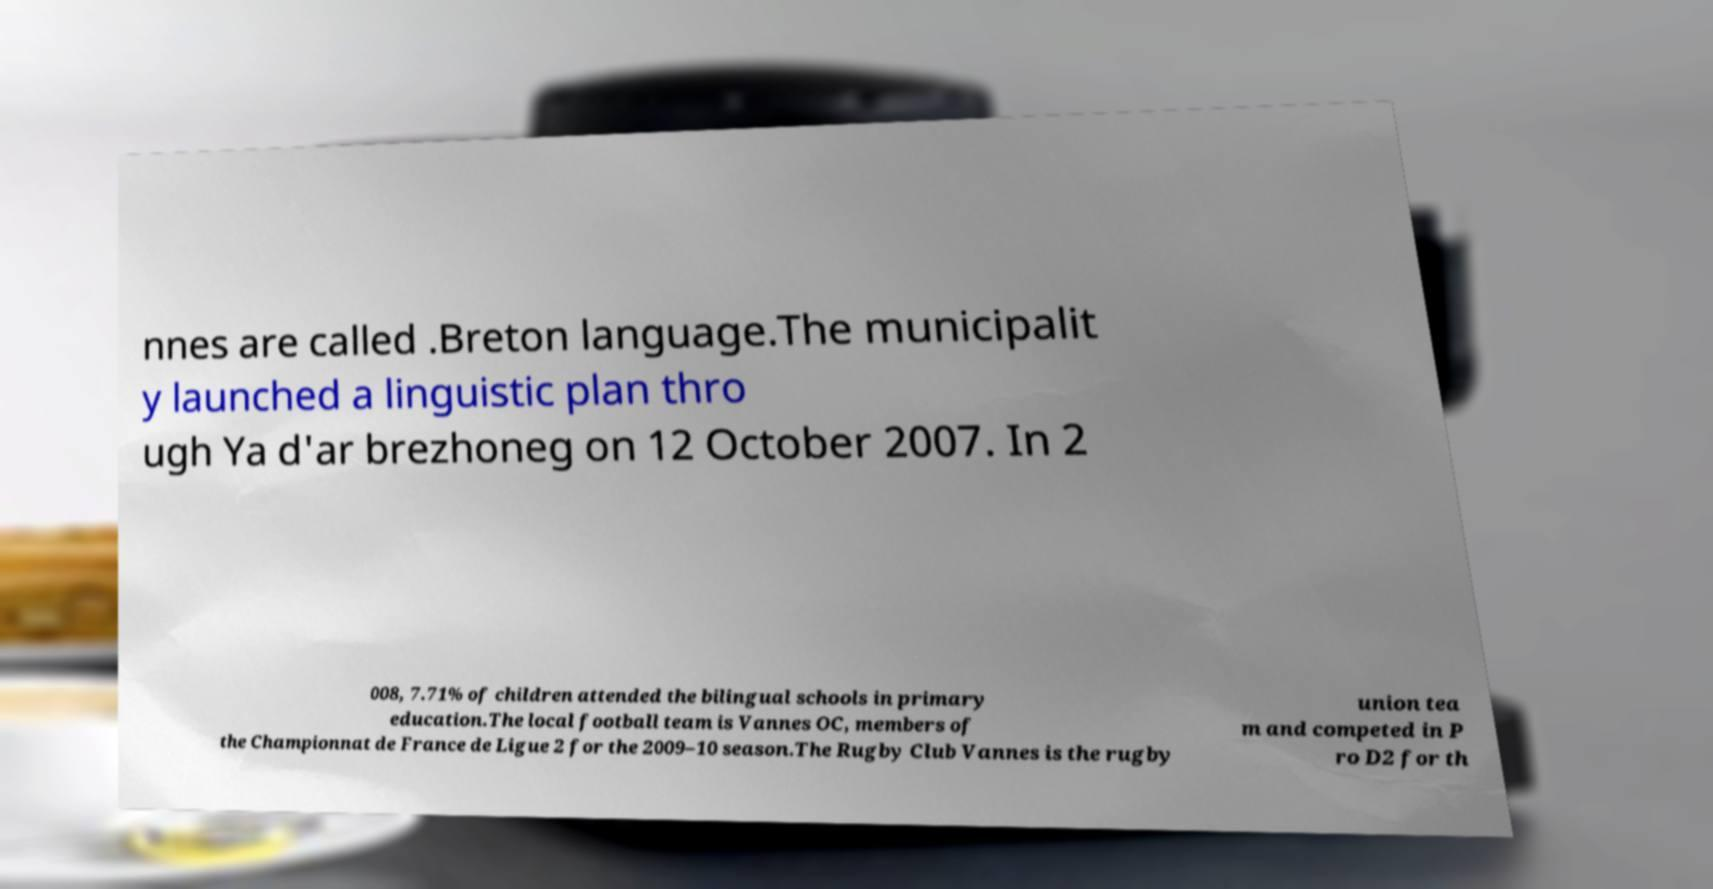Could you extract and type out the text from this image? nnes are called .Breton language.The municipalit y launched a linguistic plan thro ugh Ya d'ar brezhoneg on 12 October 2007. In 2 008, 7.71% of children attended the bilingual schools in primary education.The local football team is Vannes OC, members of the Championnat de France de Ligue 2 for the 2009–10 season.The Rugby Club Vannes is the rugby union tea m and competed in P ro D2 for th 